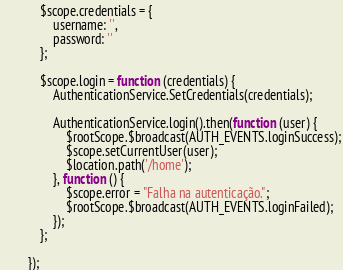Convert code to text. <code><loc_0><loc_0><loc_500><loc_500><_JavaScript_>            $scope.credentials = {
                username: '',
                password: ''
            };

            $scope.login = function (credentials) {
                AuthenticationService.SetCredentials(credentials);

                AuthenticationService.login().then(function (user) {
                    $rootScope.$broadcast(AUTH_EVENTS.loginSuccess);
                    $scope.setCurrentUser(user);
                    $location.path('/home');
                }, function () {
                    $scope.error = "Falha na autenticação.";
                    $rootScope.$broadcast(AUTH_EVENTS.loginFailed);
                });
            };

        });</code> 